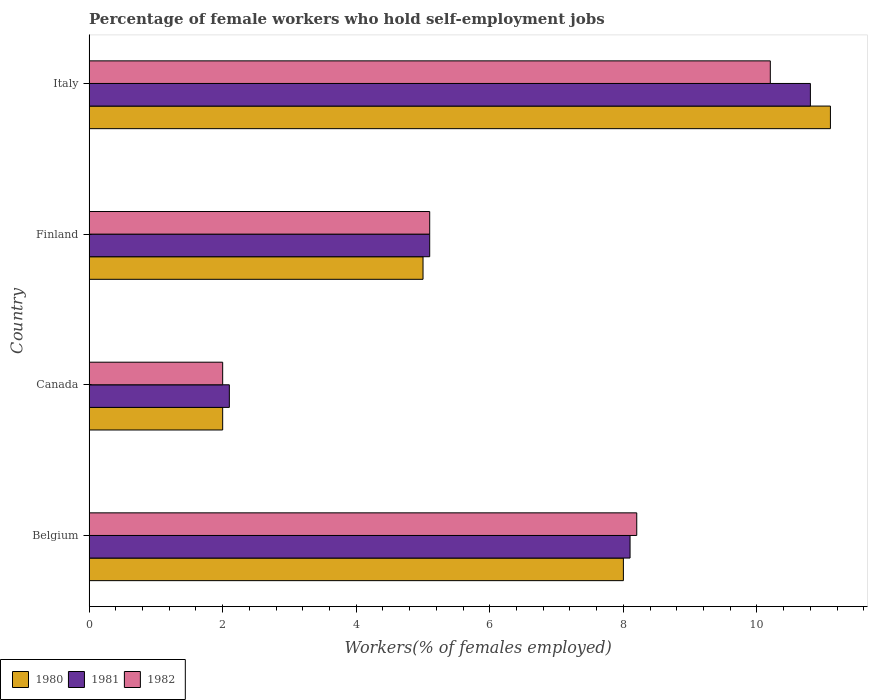How many different coloured bars are there?
Provide a short and direct response. 3. How many groups of bars are there?
Give a very brief answer. 4. Are the number of bars on each tick of the Y-axis equal?
Your response must be concise. Yes. What is the label of the 2nd group of bars from the top?
Your answer should be compact. Finland. In how many cases, is the number of bars for a given country not equal to the number of legend labels?
Offer a very short reply. 0. What is the percentage of self-employed female workers in 1981 in Canada?
Provide a short and direct response. 2.1. Across all countries, what is the maximum percentage of self-employed female workers in 1981?
Provide a succinct answer. 10.8. In which country was the percentage of self-employed female workers in 1982 maximum?
Make the answer very short. Italy. In which country was the percentage of self-employed female workers in 1982 minimum?
Ensure brevity in your answer.  Canada. What is the total percentage of self-employed female workers in 1982 in the graph?
Keep it short and to the point. 25.5. What is the difference between the percentage of self-employed female workers in 1980 in Canada and that in Italy?
Your response must be concise. -9.1. What is the difference between the percentage of self-employed female workers in 1980 in Canada and the percentage of self-employed female workers in 1981 in Belgium?
Give a very brief answer. -6.1. What is the average percentage of self-employed female workers in 1980 per country?
Your answer should be compact. 6.53. What is the difference between the percentage of self-employed female workers in 1980 and percentage of self-employed female workers in 1982 in Canada?
Provide a short and direct response. 0. What is the ratio of the percentage of self-employed female workers in 1982 in Belgium to that in Canada?
Provide a short and direct response. 4.1. Is the percentage of self-employed female workers in 1981 in Belgium less than that in Finland?
Provide a succinct answer. No. What is the difference between the highest and the second highest percentage of self-employed female workers in 1980?
Provide a succinct answer. 3.1. What is the difference between the highest and the lowest percentage of self-employed female workers in 1980?
Provide a succinct answer. 9.1. In how many countries, is the percentage of self-employed female workers in 1980 greater than the average percentage of self-employed female workers in 1980 taken over all countries?
Offer a terse response. 2. Is the sum of the percentage of self-employed female workers in 1981 in Canada and Finland greater than the maximum percentage of self-employed female workers in 1982 across all countries?
Ensure brevity in your answer.  No. What does the 1st bar from the bottom in Belgium represents?
Ensure brevity in your answer.  1980. Is it the case that in every country, the sum of the percentage of self-employed female workers in 1981 and percentage of self-employed female workers in 1982 is greater than the percentage of self-employed female workers in 1980?
Ensure brevity in your answer.  Yes. Are all the bars in the graph horizontal?
Keep it short and to the point. Yes. Are the values on the major ticks of X-axis written in scientific E-notation?
Provide a short and direct response. No. Does the graph contain grids?
Provide a short and direct response. No. Where does the legend appear in the graph?
Give a very brief answer. Bottom left. How many legend labels are there?
Your answer should be very brief. 3. How are the legend labels stacked?
Offer a terse response. Horizontal. What is the title of the graph?
Make the answer very short. Percentage of female workers who hold self-employment jobs. Does "2004" appear as one of the legend labels in the graph?
Ensure brevity in your answer.  No. What is the label or title of the X-axis?
Give a very brief answer. Workers(% of females employed). What is the Workers(% of females employed) in 1980 in Belgium?
Your response must be concise. 8. What is the Workers(% of females employed) of 1981 in Belgium?
Offer a very short reply. 8.1. What is the Workers(% of females employed) in 1982 in Belgium?
Keep it short and to the point. 8.2. What is the Workers(% of females employed) in 1980 in Canada?
Your answer should be compact. 2. What is the Workers(% of females employed) of 1981 in Canada?
Provide a succinct answer. 2.1. What is the Workers(% of females employed) of 1981 in Finland?
Ensure brevity in your answer.  5.1. What is the Workers(% of females employed) in 1982 in Finland?
Give a very brief answer. 5.1. What is the Workers(% of females employed) of 1980 in Italy?
Offer a terse response. 11.1. What is the Workers(% of females employed) of 1981 in Italy?
Give a very brief answer. 10.8. What is the Workers(% of females employed) of 1982 in Italy?
Your answer should be very brief. 10.2. Across all countries, what is the maximum Workers(% of females employed) of 1980?
Keep it short and to the point. 11.1. Across all countries, what is the maximum Workers(% of females employed) of 1981?
Your response must be concise. 10.8. Across all countries, what is the maximum Workers(% of females employed) of 1982?
Ensure brevity in your answer.  10.2. Across all countries, what is the minimum Workers(% of females employed) of 1981?
Your answer should be very brief. 2.1. What is the total Workers(% of females employed) in 1980 in the graph?
Ensure brevity in your answer.  26.1. What is the total Workers(% of females employed) of 1981 in the graph?
Offer a very short reply. 26.1. What is the total Workers(% of females employed) of 1982 in the graph?
Your answer should be compact. 25.5. What is the difference between the Workers(% of females employed) in 1982 in Belgium and that in Canada?
Make the answer very short. 6.2. What is the difference between the Workers(% of females employed) of 1981 in Belgium and that in Finland?
Give a very brief answer. 3. What is the difference between the Workers(% of females employed) in 1980 in Belgium and that in Italy?
Your answer should be very brief. -3.1. What is the difference between the Workers(% of females employed) of 1982 in Belgium and that in Italy?
Ensure brevity in your answer.  -2. What is the difference between the Workers(% of females employed) of 1981 in Canada and that in Finland?
Provide a short and direct response. -3. What is the difference between the Workers(% of females employed) of 1982 in Canada and that in Finland?
Offer a terse response. -3.1. What is the difference between the Workers(% of females employed) of 1980 in Canada and that in Italy?
Provide a short and direct response. -9.1. What is the difference between the Workers(% of females employed) of 1980 in Belgium and the Workers(% of females employed) of 1981 in Canada?
Your response must be concise. 5.9. What is the difference between the Workers(% of females employed) of 1980 in Belgium and the Workers(% of females employed) of 1982 in Canada?
Your answer should be compact. 6. What is the difference between the Workers(% of females employed) in 1980 in Belgium and the Workers(% of females employed) in 1982 in Finland?
Your answer should be compact. 2.9. What is the difference between the Workers(% of females employed) in 1980 in Belgium and the Workers(% of females employed) in 1981 in Italy?
Your response must be concise. -2.8. What is the difference between the Workers(% of females employed) in 1980 in Canada and the Workers(% of females employed) in 1982 in Finland?
Keep it short and to the point. -3.1. What is the difference between the Workers(% of females employed) of 1980 in Finland and the Workers(% of females employed) of 1981 in Italy?
Provide a succinct answer. -5.8. What is the difference between the Workers(% of females employed) in 1980 in Finland and the Workers(% of females employed) in 1982 in Italy?
Offer a very short reply. -5.2. What is the average Workers(% of females employed) of 1980 per country?
Give a very brief answer. 6.53. What is the average Workers(% of females employed) in 1981 per country?
Give a very brief answer. 6.53. What is the average Workers(% of females employed) of 1982 per country?
Give a very brief answer. 6.38. What is the difference between the Workers(% of females employed) in 1980 and Workers(% of females employed) in 1981 in Canada?
Provide a short and direct response. -0.1. What is the difference between the Workers(% of females employed) in 1980 and Workers(% of females employed) in 1981 in Finland?
Make the answer very short. -0.1. What is the difference between the Workers(% of females employed) in 1980 and Workers(% of females employed) in 1982 in Finland?
Make the answer very short. -0.1. What is the difference between the Workers(% of females employed) of 1981 and Workers(% of females employed) of 1982 in Finland?
Provide a succinct answer. 0. What is the difference between the Workers(% of females employed) in 1980 and Workers(% of females employed) in 1981 in Italy?
Offer a terse response. 0.3. What is the difference between the Workers(% of females employed) in 1980 and Workers(% of females employed) in 1982 in Italy?
Give a very brief answer. 0.9. What is the difference between the Workers(% of females employed) of 1981 and Workers(% of females employed) of 1982 in Italy?
Ensure brevity in your answer.  0.6. What is the ratio of the Workers(% of females employed) in 1981 in Belgium to that in Canada?
Make the answer very short. 3.86. What is the ratio of the Workers(% of females employed) in 1980 in Belgium to that in Finland?
Your answer should be very brief. 1.6. What is the ratio of the Workers(% of females employed) of 1981 in Belgium to that in Finland?
Offer a very short reply. 1.59. What is the ratio of the Workers(% of females employed) in 1982 in Belgium to that in Finland?
Ensure brevity in your answer.  1.61. What is the ratio of the Workers(% of females employed) of 1980 in Belgium to that in Italy?
Give a very brief answer. 0.72. What is the ratio of the Workers(% of females employed) in 1982 in Belgium to that in Italy?
Provide a short and direct response. 0.8. What is the ratio of the Workers(% of females employed) in 1980 in Canada to that in Finland?
Your answer should be compact. 0.4. What is the ratio of the Workers(% of females employed) of 1981 in Canada to that in Finland?
Ensure brevity in your answer.  0.41. What is the ratio of the Workers(% of females employed) of 1982 in Canada to that in Finland?
Offer a very short reply. 0.39. What is the ratio of the Workers(% of females employed) of 1980 in Canada to that in Italy?
Give a very brief answer. 0.18. What is the ratio of the Workers(% of females employed) in 1981 in Canada to that in Italy?
Your answer should be very brief. 0.19. What is the ratio of the Workers(% of females employed) of 1982 in Canada to that in Italy?
Make the answer very short. 0.2. What is the ratio of the Workers(% of females employed) of 1980 in Finland to that in Italy?
Make the answer very short. 0.45. What is the ratio of the Workers(% of females employed) in 1981 in Finland to that in Italy?
Make the answer very short. 0.47. What is the difference between the highest and the second highest Workers(% of females employed) of 1980?
Your answer should be compact. 3.1. What is the difference between the highest and the second highest Workers(% of females employed) in 1982?
Offer a very short reply. 2. What is the difference between the highest and the lowest Workers(% of females employed) in 1982?
Make the answer very short. 8.2. 